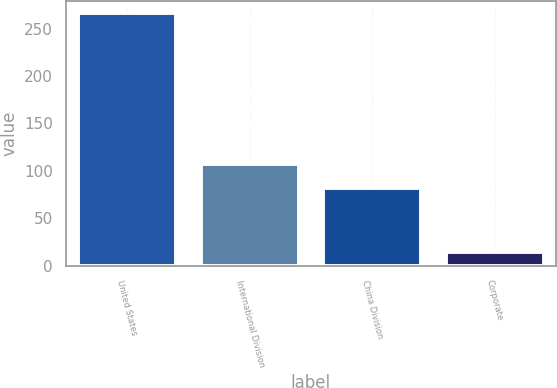Convert chart. <chart><loc_0><loc_0><loc_500><loc_500><bar_chart><fcel>United States<fcel>International Division<fcel>China Division<fcel>Corporate<nl><fcel>266<fcel>107.2<fcel>82<fcel>14<nl></chart> 